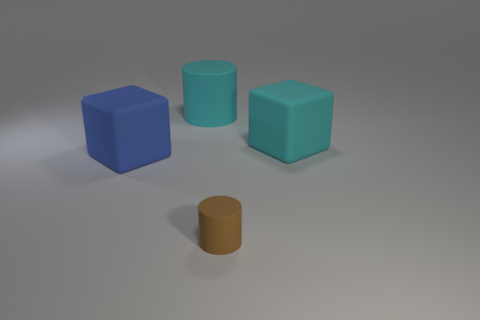Add 4 small shiny spheres. How many objects exist? 8 Subtract 0 yellow cubes. How many objects are left? 4 Subtract all large red matte things. Subtract all blue rubber cubes. How many objects are left? 3 Add 1 brown rubber objects. How many brown rubber objects are left? 2 Add 2 blue matte cubes. How many blue matte cubes exist? 3 